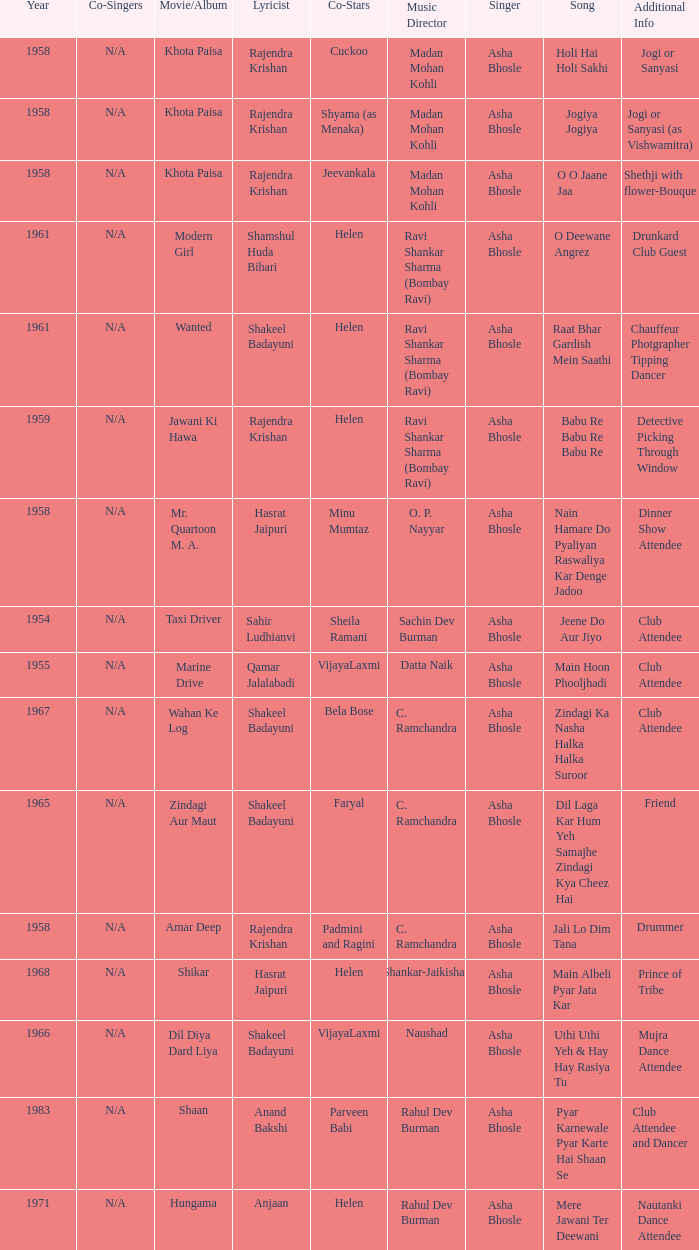What movie did Bela Bose co-star in? Wahan Ke Log. 